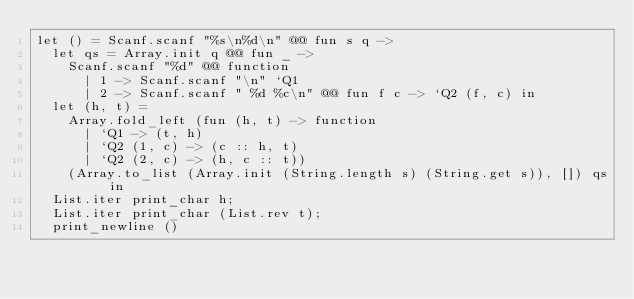Convert code to text. <code><loc_0><loc_0><loc_500><loc_500><_OCaml_>let () = Scanf.scanf "%s\n%d\n" @@ fun s q ->
  let qs = Array.init q @@ fun _ ->
    Scanf.scanf "%d" @@ function
      | 1 -> Scanf.scanf "\n" `Q1
      | 2 -> Scanf.scanf " %d %c\n" @@ fun f c -> `Q2 (f, c) in
  let (h, t) =
    Array.fold_left (fun (h, t) -> function
      | `Q1 -> (t, h)
      | `Q2 (1, c) -> (c :: h, t)
      | `Q2 (2, c) -> (h, c :: t))
    (Array.to_list (Array.init (String.length s) (String.get s)), []) qs in
  List.iter print_char h;
  List.iter print_char (List.rev t);
  print_newline ()</code> 